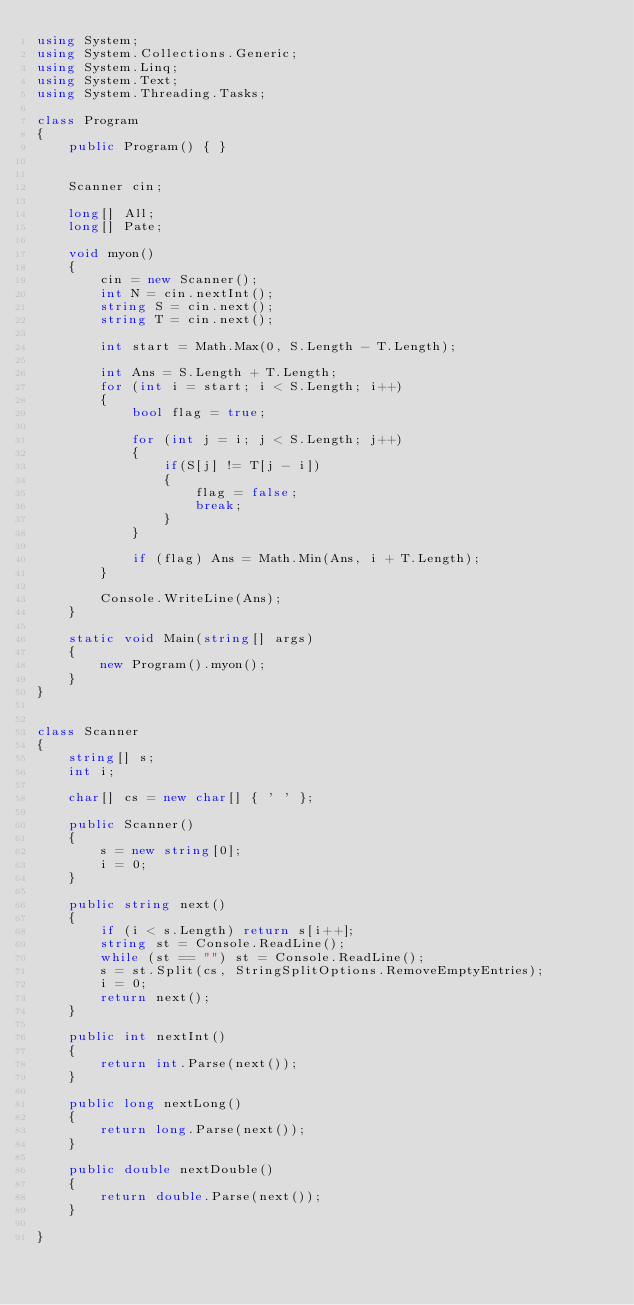Convert code to text. <code><loc_0><loc_0><loc_500><loc_500><_C#_>using System;
using System.Collections.Generic;
using System.Linq;
using System.Text;
using System.Threading.Tasks;

class Program
{
    public Program() { }


    Scanner cin;

    long[] All;
    long[] Pate;

    void myon()
    {
        cin = new Scanner();
        int N = cin.nextInt();
        string S = cin.next();
        string T = cin.next();

        int start = Math.Max(0, S.Length - T.Length);

        int Ans = S.Length + T.Length;
        for (int i = start; i < S.Length; i++)
        {
            bool flag = true;

            for (int j = i; j < S.Length; j++)
            {
                if(S[j] != T[j - i])
                {
                    flag = false;
                    break;
                }
            }

            if (flag) Ans = Math.Min(Ans, i + T.Length);
        }

        Console.WriteLine(Ans);
    }

    static void Main(string[] args)
    {
        new Program().myon();
    }
}


class Scanner
{
    string[] s;
    int i;

    char[] cs = new char[] { ' ' };

    public Scanner()
    {
        s = new string[0];
        i = 0;
    }

    public string next()
    {
        if (i < s.Length) return s[i++];
        string st = Console.ReadLine();
        while (st == "") st = Console.ReadLine();
        s = st.Split(cs, StringSplitOptions.RemoveEmptyEntries);
        i = 0;
        return next();
    }

    public int nextInt()
    {
        return int.Parse(next());
    }

    public long nextLong()
    {
        return long.Parse(next());
    }

    public double nextDouble()
    {
        return double.Parse(next());
    }

}
</code> 